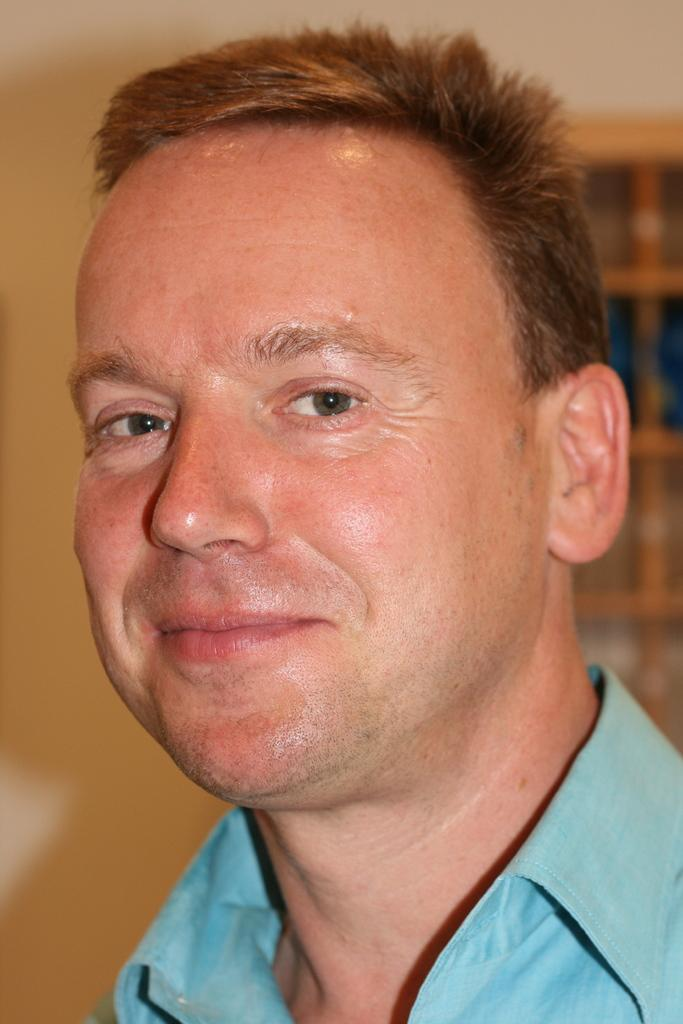Who is present in the image? There is a man in the image. What is the man wearing? The man is wearing a blue shirt. What can be seen in the background of the image? There is a wall and a window in the background of the image. What type of temper does the man have in the image? There is no indication of the man's temper in the image, as it is not possible to determine his emotional state from a still photograph. 